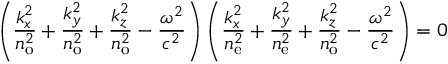<formula> <loc_0><loc_0><loc_500><loc_500>\left ( { \frac { k _ { x } ^ { 2 } } { n _ { o } ^ { 2 } } } + { \frac { k _ { y } ^ { 2 } } { n _ { o } ^ { 2 } } } + { \frac { k _ { z } ^ { 2 } } { n _ { o } ^ { 2 } } } - { \frac { \omega ^ { 2 } } { c ^ { 2 } } } \right ) \left ( { \frac { k _ { x } ^ { 2 } } { n _ { e } ^ { 2 } } } + { \frac { k _ { y } ^ { 2 } } { n _ { e } ^ { 2 } } } + { \frac { k _ { z } ^ { 2 } } { n _ { o } ^ { 2 } } } - { \frac { \omega ^ { 2 } } { c ^ { 2 } } } \right ) = 0</formula> 